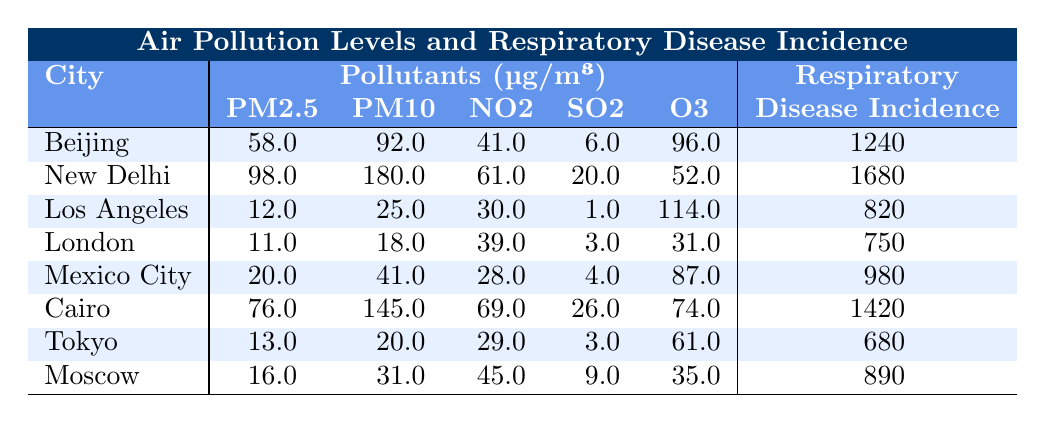What is the respiratory disease incidence in New Delhi? The table shows that New Delhi has a respiratory disease incidence of 1680.
Answer: 1680 Which city has the highest PM2.5 level? From the table, New Delhi has the highest PM2.5 level at 98.0 µg/m³.
Answer: New Delhi What is the average PM10 level for all cities listed? To find the average PM10 level, sum the PM10 values (92 + 180 + 25 + 18 + 41 + 145 + 20 + 31) = 512. There are 8 cities, so the average PM10 level is 512/8 = 64.0.
Answer: 64.0 Is the respiratory disease incidence higher in Beijing than in Los Angeles? Beijing has a respiratory disease incidence of 1240, while Los Angeles has 820. Since 1240 > 820, the answer is yes.
Answer: Yes What is the difference in respiratory disease incidence between Cairo and Mexico City? The incidence in Cairo is 1420, and in Mexico City, it is 980. The difference is 1420 - 980 = 440.
Answer: 440 Which city has the lowest level of O3? The table indicates that Tokyo has the lowest O3 level at 61.0 µg/m³.
Answer: Tokyo How does the PM2.5 level in Cairo compare to that in Los Angeles? Cairo has a PM2.5 level of 76.0, while Los Angeles has a PM2.5 level of 12.0. Since 76.0 > 12.0, Cairo has a higher PM2.5 level.
Answer: Cairo has a higher PM2.5 level Which pollutants are above 60 µg/m³ in New Delhi? In New Delhi, PM2.5 (98.0), PM10 (180.0), and NO2 (61.0) are above 60 µg/m³.
Answer: PM2.5, PM10, NO2 If we consider only the top three cities by respiratory disease incidence, what is their average PM10 level? The top three cities by respiratory disease incidence are New Delhi (180.0), Cairo (145.0), and Beijing (92.0). The average PM10 is (180 + 145 + 92) / 3 = 139.0.
Answer: 139.0 Are there any cities where SO2 levels are higher than 10 µg/m³? From the table, Cairo (26.0) and New Delhi (20.0) have SO2 levels higher than 10 µg/m³.
Answer: Yes, Cairo and New Delhi 